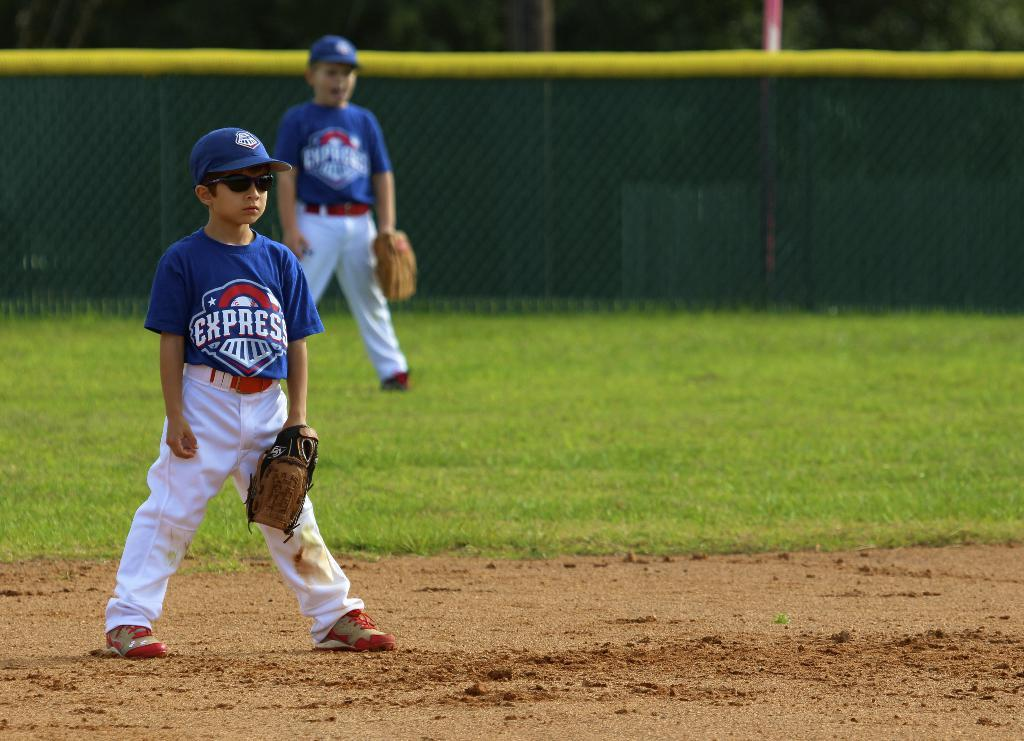<image>
Create a compact narrative representing the image presented. Young athlete with sunglasses on an a blue jersey that has Express on it. 